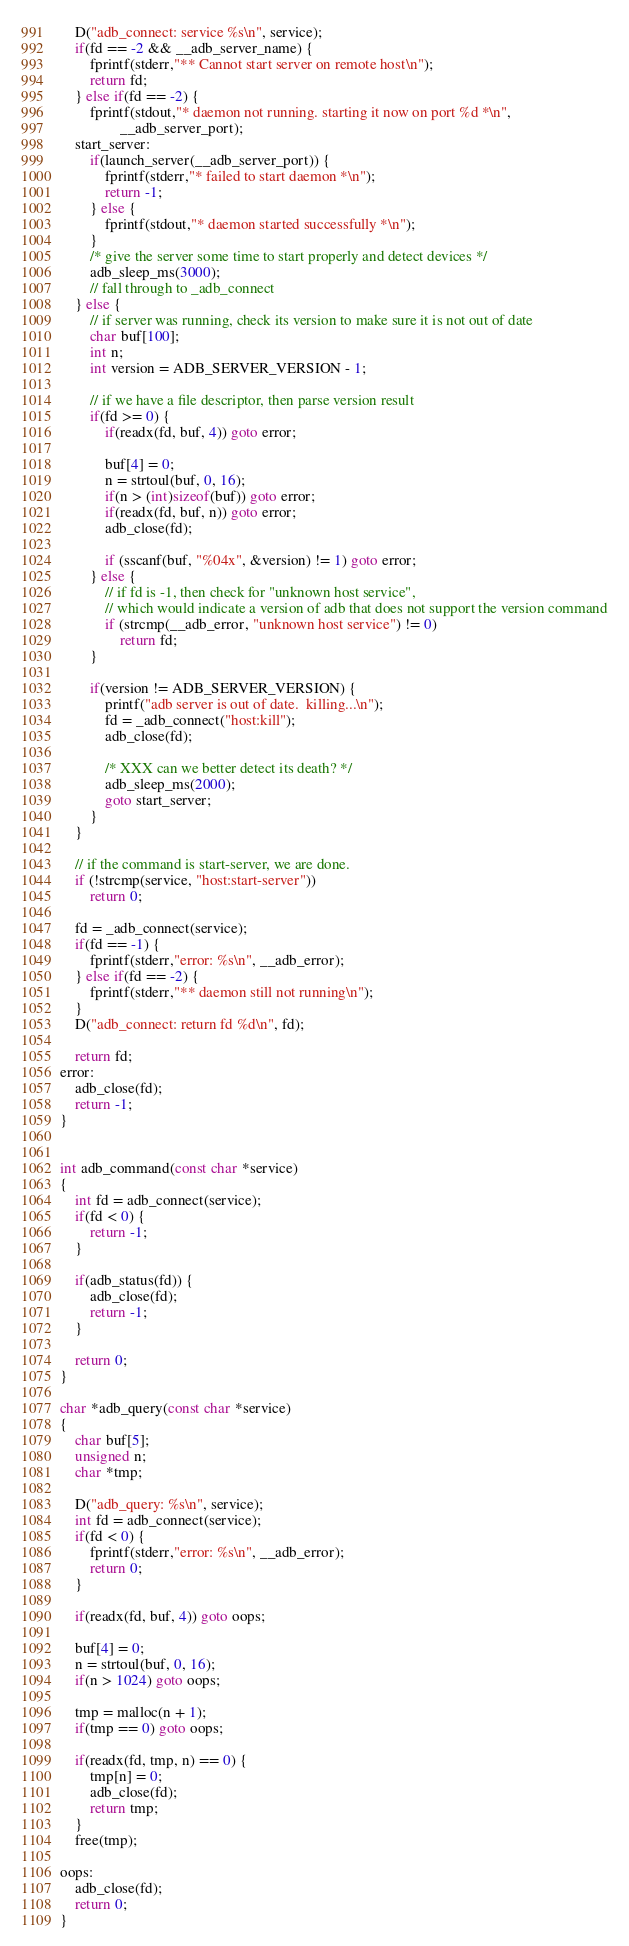<code> <loc_0><loc_0><loc_500><loc_500><_C_>    D("adb_connect: service %s\n", service);
    if(fd == -2 && __adb_server_name) {
        fprintf(stderr,"** Cannot start server on remote host\n");
        return fd;
    } else if(fd == -2) {
        fprintf(stdout,"* daemon not running. starting it now on port %d *\n",
                __adb_server_port);
    start_server:
        if(launch_server(__adb_server_port)) {
            fprintf(stderr,"* failed to start daemon *\n");
            return -1;
        } else {
            fprintf(stdout,"* daemon started successfully *\n");
        }
        /* give the server some time to start properly and detect devices */
        adb_sleep_ms(3000);
        // fall through to _adb_connect
    } else {
        // if server was running, check its version to make sure it is not out of date
        char buf[100];
        int n;
        int version = ADB_SERVER_VERSION - 1;

        // if we have a file descriptor, then parse version result
        if(fd >= 0) {
            if(readx(fd, buf, 4)) goto error;

            buf[4] = 0;
            n = strtoul(buf, 0, 16);
            if(n > (int)sizeof(buf)) goto error;
            if(readx(fd, buf, n)) goto error;
            adb_close(fd);

            if (sscanf(buf, "%04x", &version) != 1) goto error;
        } else {
            // if fd is -1, then check for "unknown host service",
            // which would indicate a version of adb that does not support the version command
            if (strcmp(__adb_error, "unknown host service") != 0)
                return fd;
        }

        if(version != ADB_SERVER_VERSION) {
            printf("adb server is out of date.  killing...\n");
            fd = _adb_connect("host:kill");
            adb_close(fd);

            /* XXX can we better detect its death? */
            adb_sleep_ms(2000);
            goto start_server;
        }
    }

    // if the command is start-server, we are done.
    if (!strcmp(service, "host:start-server"))
        return 0;

    fd = _adb_connect(service);
    if(fd == -1) {
        fprintf(stderr,"error: %s\n", __adb_error);
    } else if(fd == -2) {
        fprintf(stderr,"** daemon still not running\n");
    }
    D("adb_connect: return fd %d\n", fd);

    return fd;
error:
    adb_close(fd);
    return -1;
}


int adb_command(const char *service)
{
    int fd = adb_connect(service);
    if(fd < 0) {
        return -1;
    }

    if(adb_status(fd)) {
        adb_close(fd);
        return -1;
    }

    return 0;
}

char *adb_query(const char *service)
{
    char buf[5];
    unsigned n;
    char *tmp;

    D("adb_query: %s\n", service);
    int fd = adb_connect(service);
    if(fd < 0) {
        fprintf(stderr,"error: %s\n", __adb_error);
        return 0;
    }

    if(readx(fd, buf, 4)) goto oops;

    buf[4] = 0;
    n = strtoul(buf, 0, 16);
    if(n > 1024) goto oops;

    tmp = malloc(n + 1);
    if(tmp == 0) goto oops;

    if(readx(fd, tmp, n) == 0) {
        tmp[n] = 0;
        adb_close(fd);
        return tmp;
    }
    free(tmp);

oops:
    adb_close(fd);
    return 0;
}
</code> 